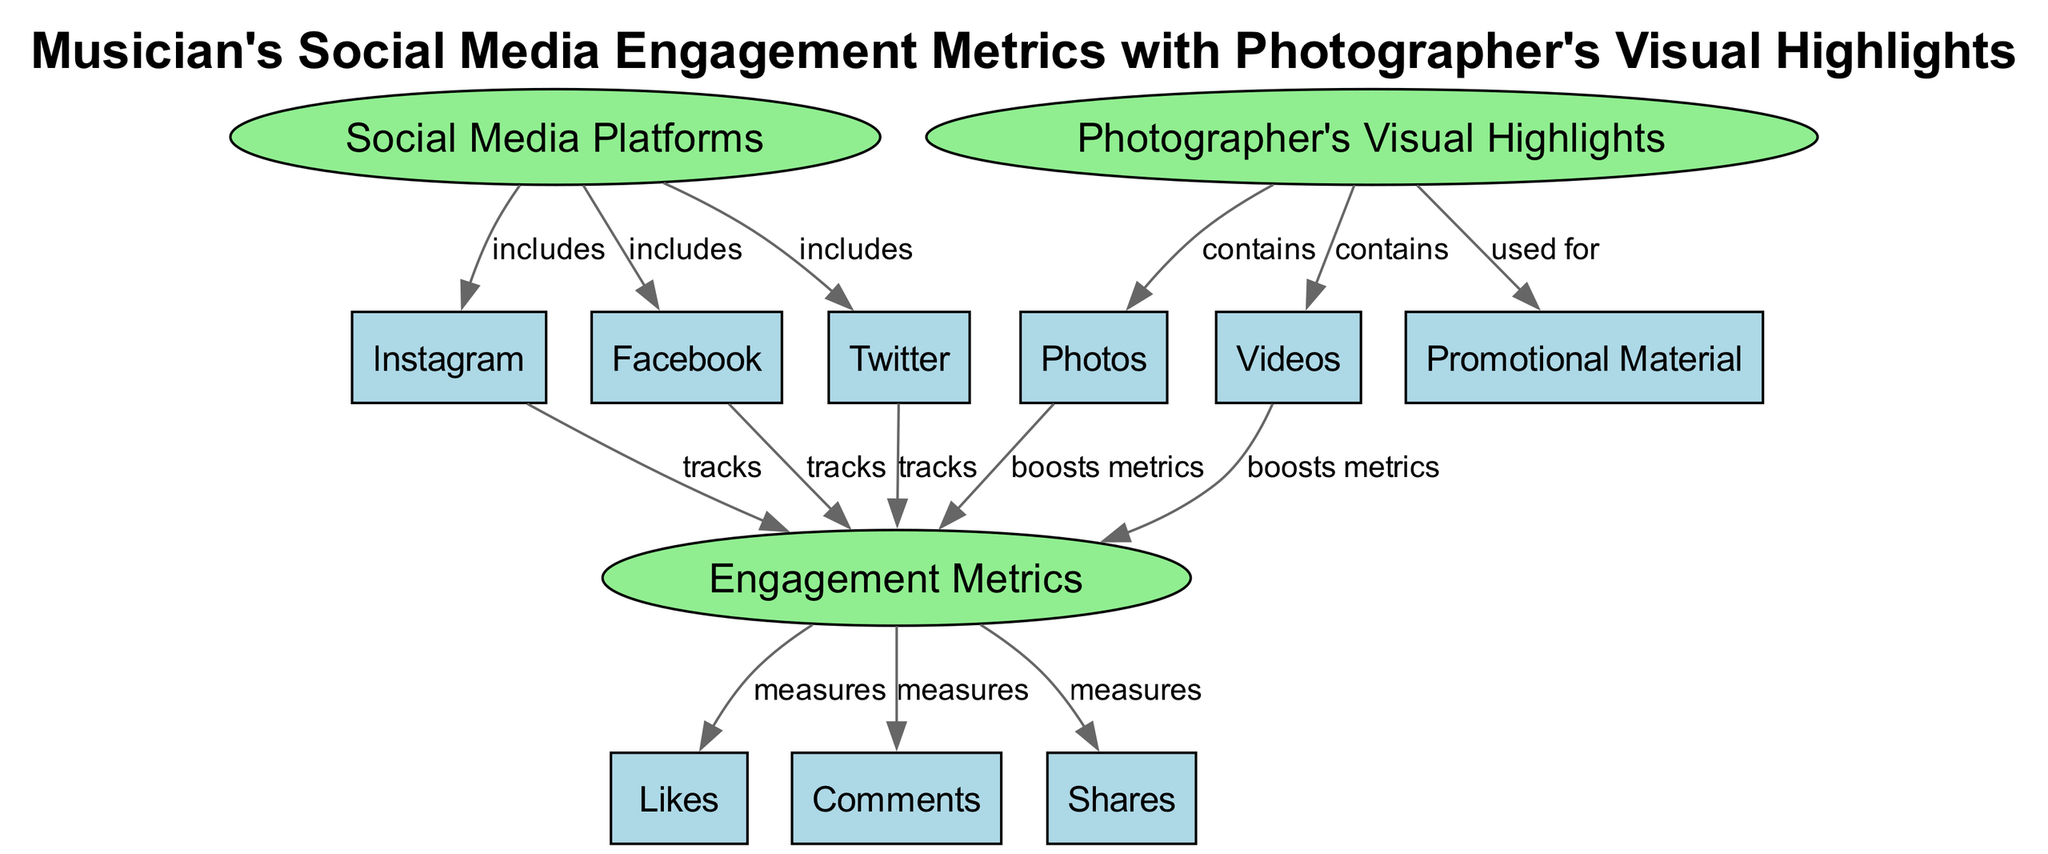What are the social media platforms included in this diagram? The diagram lists three social media platforms under the node "Social Media Platforms": Instagram, Facebook, and Twitter. Thus, the answer includes all these platforms.
Answer: Instagram, Facebook, Twitter How many engagement metrics are measured in the diagram? There are three engagement metrics shown connected to the node "Engagement Metrics": Likes, Comments, and Shares. Therefore, the total count is three.
Answer: three What kind of content does the photographer's visual highlights contain? The diagram specifies that the photographer's visual highlights contain two types of content: Photos and Videos. This can be found directly under the node "Photographer's Visual Highlights."
Answer: Photos, Videos How do the visual highlights boost engagement metrics? The diagram indicates two connections from the visual highlights. Photos and Videos are both labeled as boosting the engagement metrics, suggesting a direct link between the content produced by the photographer and the engagement levels measured.
Answer: Photos, Videos What relationship exists between social media platforms and engagement metrics? The diagram shows that each social media platform tracks the engagement metrics. This means that each of the three platforms (Instagram, Facebook, Twitter) actively measures the engagement such as Likes, Comments, and Shares.
Answer: tracks Which visual highlights are used for promotional material? According to the diagram, the connection specifies that the content from the photographer's visual highlights, emphasizing the use of both Photos and Videos, is categorized as used for creating promotional material.
Answer: Photos, Videos What do the engagement metrics measure? The engagement metrics measure three specific aspects: Likes, Comments, and Shares. This is clearly indicated in the diagram, showing how these types of interactions are quantified.
Answer: Likes, Comments, Shares Which node has the most connections in the diagram? The node "Engagement Metrics" has three edges leading to it, indicating how many metrics are measured (Likes, Comments, and Shares). This is the highest number of connections in the diagram compared to other nodes.
Answer: Engagement Metrics How many total nodes are present in the diagram? By counting each unique entry in the nodes section of the diagram, we find there are twelve nodes (including social media platforms, engagement metrics, and photographer highlights).
Answer: twelve 